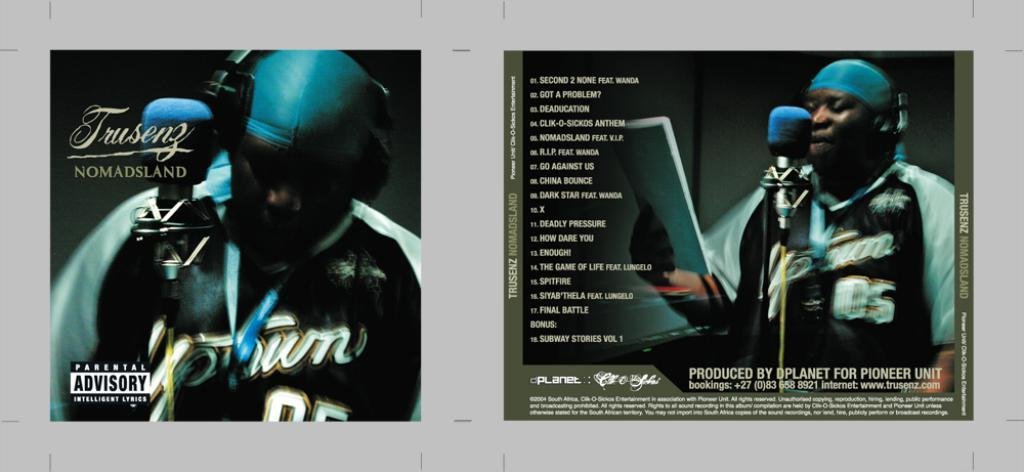<image>
Give a short and clear explanation of the subsequent image. a CD that is called Nomadsland with many songs on it 